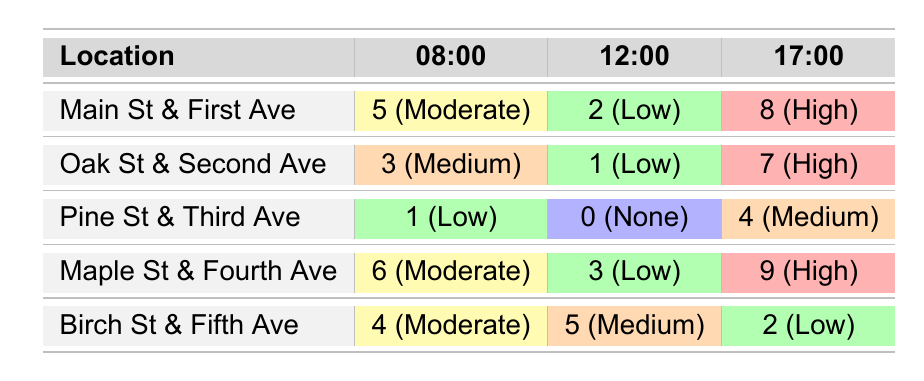What is the total number of incidents reported at Main St & First Ave? From the table, the incidents reported at Main St & First Ave are 5 at 08:00, 2 at 12:00, and 8 at 17:00. Adding these values together gives 5 + 2 + 8 = 15.
Answer: 15 How many incidents were reported at Pine St & Third Ave during the day? At Pine St & Third Ave, the incidents reported are 1 at 08:00, 0 at 12:00, and 4 at 17:00. Adding these gives 1 + 0 + 4 = 5.
Answer: 5 Is there a time period where no incidents were reported at Pine St & Third Ave? The table shows that at 12:00 at Pine St & Third Ave, the incidents reported are 0, indicating that there were no incidents during that time.
Answer: Yes At which location and time was the highest number of incidents reported? The highest number of incidents reported is 9 at Maple St & Fourth Ave at 17:00.
Answer: Maple St & Fourth Ave at 17:00 What is the average number of incidents reported at Oak St & Second Ave across the three times? The incidents reported at Oak St & Second Ave are 3 at 08:00, 1 at 12:00, and 7 at 17:00. The total incidents are 3 + 1 + 7 = 11. Dividing by the 3 time periods gives an average of 11/3 ≈ 3.67.
Answer: Approximately 3.67 Which location had the highest severity level reported the most times? The highest severity level reported is "High" and occurred at Main St & First Ave (1 time) and Maple St & Fourth Ave (1 time) at 17:00, and Oak St & Second Ave (1 time) at 17:00. There are 3 locations, but each only once.
Answer: None had it more than once What is the difference in the number of incidents reported between 08:00 and 17:00 for Birch St & Fifth Ave? At Birch St & Fifth Ave, there are 4 incidents at 08:00 and 2 at 17:00. The difference is 4 - 2 = 2 incidents.
Answer: 2 incidents Which location had the most varied severity levels throughout the day? The severity levels at Birch St & Fifth Ave range from Medium to Low and Moderate across the times, showing variation. Comparatively, Pine St & Third Ave had none at noon. More locations had varied, but Birch has three types.
Answer: Birch St & Fifth Ave 